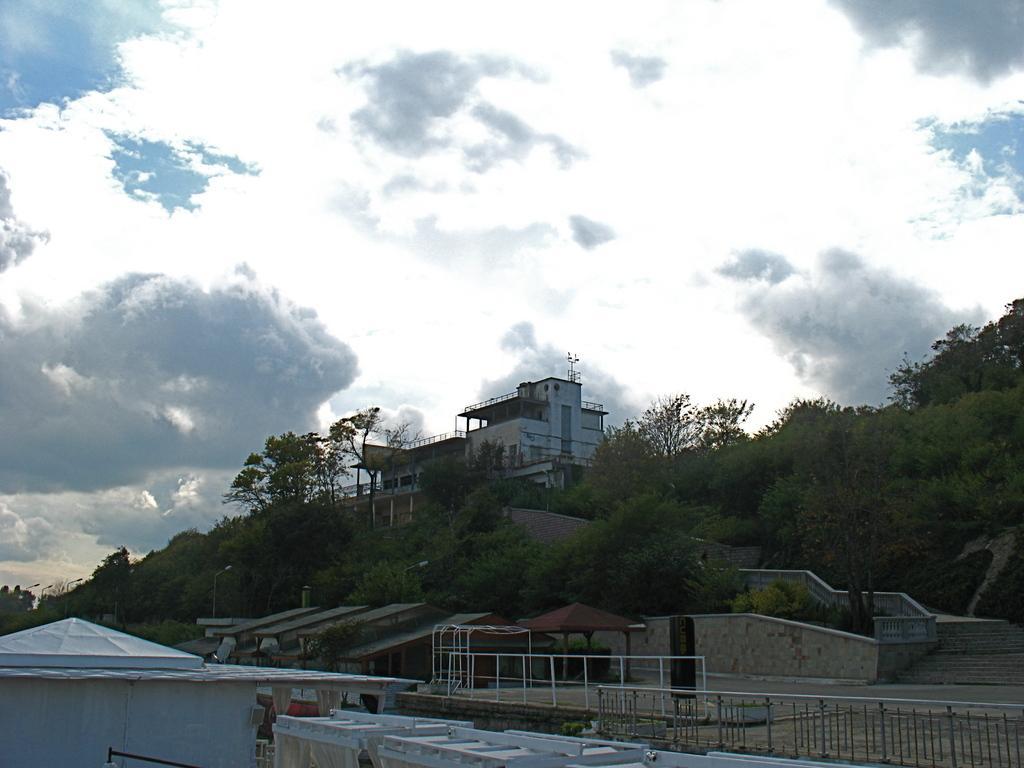In one or two sentences, can you explain what this image depicts? On the left side, there is a shelter. On the right side, there are fences and there are shelters. In the background, there are trees, a wall and a building on a hill and there are clouds in the sky. 